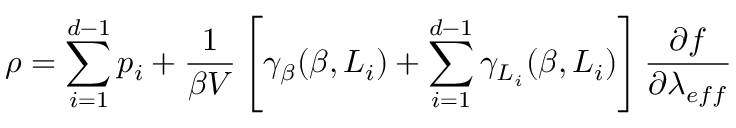Convert formula to latex. <formula><loc_0><loc_0><loc_500><loc_500>\rho = \sum _ { i = 1 } ^ { d - 1 } p _ { i } + \frac { 1 } { \beta V } \left [ \gamma _ { \beta } ( \beta , L _ { i } ) + \sum _ { i = 1 } ^ { d - 1 } \gamma _ { L _ { i } } ( \beta , L _ { i } ) \right ] \frac { \partial f } { \partial \lambda _ { e f f } }</formula> 